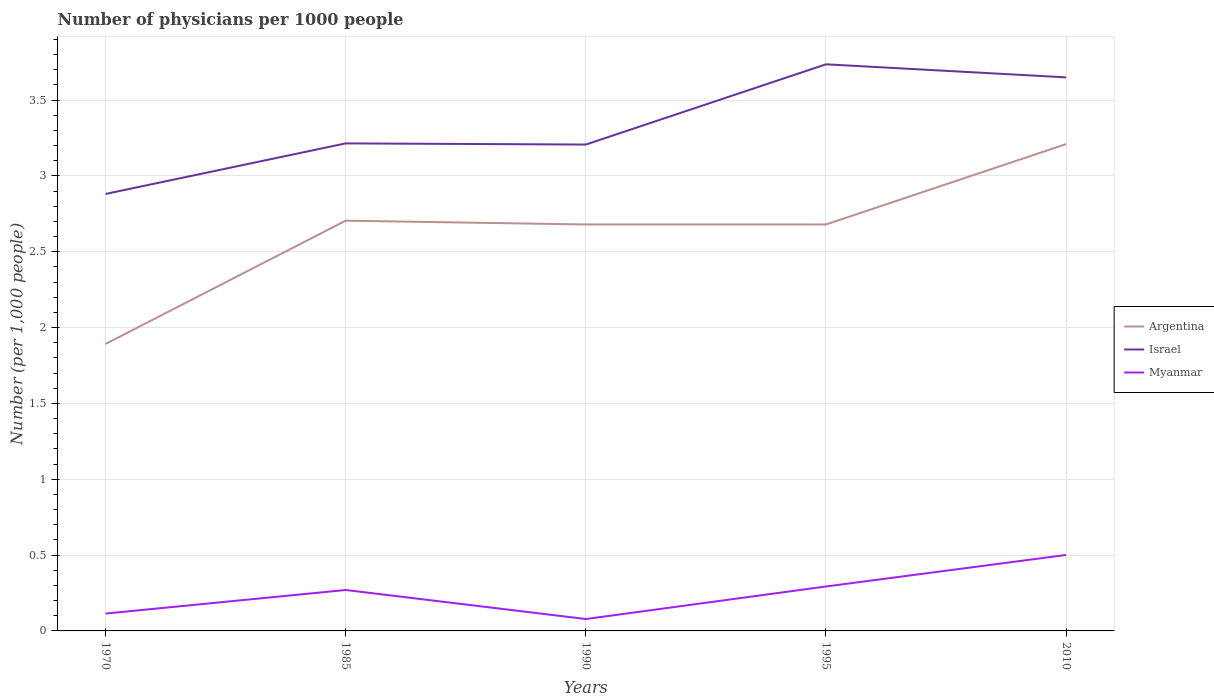Does the line corresponding to Israel intersect with the line corresponding to Argentina?
Your answer should be very brief. No. Across all years, what is the maximum number of physicians in Myanmar?
Make the answer very short. 0.08. What is the total number of physicians in Myanmar in the graph?
Your answer should be very brief. -0.21. What is the difference between the highest and the second highest number of physicians in Argentina?
Provide a short and direct response. 1.32. Is the number of physicians in Argentina strictly greater than the number of physicians in Israel over the years?
Your answer should be compact. Yes. How many lines are there?
Your answer should be compact. 3. Where does the legend appear in the graph?
Ensure brevity in your answer.  Center right. How are the legend labels stacked?
Your answer should be compact. Vertical. What is the title of the graph?
Make the answer very short. Number of physicians per 1000 people. Does "Hong Kong" appear as one of the legend labels in the graph?
Provide a short and direct response. No. What is the label or title of the X-axis?
Offer a terse response. Years. What is the label or title of the Y-axis?
Provide a succinct answer. Number (per 1,0 people). What is the Number (per 1,000 people) in Argentina in 1970?
Offer a very short reply. 1.89. What is the Number (per 1,000 people) in Israel in 1970?
Your answer should be compact. 2.88. What is the Number (per 1,000 people) in Myanmar in 1970?
Ensure brevity in your answer.  0.11. What is the Number (per 1,000 people) in Argentina in 1985?
Ensure brevity in your answer.  2.7. What is the Number (per 1,000 people) in Israel in 1985?
Keep it short and to the point. 3.21. What is the Number (per 1,000 people) in Myanmar in 1985?
Provide a succinct answer. 0.27. What is the Number (per 1,000 people) of Argentina in 1990?
Your answer should be compact. 2.68. What is the Number (per 1,000 people) in Israel in 1990?
Offer a very short reply. 3.21. What is the Number (per 1,000 people) in Myanmar in 1990?
Ensure brevity in your answer.  0.08. What is the Number (per 1,000 people) of Argentina in 1995?
Make the answer very short. 2.68. What is the Number (per 1,000 people) of Israel in 1995?
Make the answer very short. 3.74. What is the Number (per 1,000 people) in Myanmar in 1995?
Your answer should be very brief. 0.29. What is the Number (per 1,000 people) of Argentina in 2010?
Give a very brief answer. 3.21. What is the Number (per 1,000 people) in Israel in 2010?
Make the answer very short. 3.65. What is the Number (per 1,000 people) in Myanmar in 2010?
Keep it short and to the point. 0.5. Across all years, what is the maximum Number (per 1,000 people) in Argentina?
Provide a succinct answer. 3.21. Across all years, what is the maximum Number (per 1,000 people) in Israel?
Your answer should be very brief. 3.74. Across all years, what is the maximum Number (per 1,000 people) of Myanmar?
Provide a short and direct response. 0.5. Across all years, what is the minimum Number (per 1,000 people) in Argentina?
Make the answer very short. 1.89. Across all years, what is the minimum Number (per 1,000 people) of Israel?
Ensure brevity in your answer.  2.88. Across all years, what is the minimum Number (per 1,000 people) in Myanmar?
Make the answer very short. 0.08. What is the total Number (per 1,000 people) of Argentina in the graph?
Provide a succinct answer. 13.17. What is the total Number (per 1,000 people) of Israel in the graph?
Provide a succinct answer. 16.69. What is the total Number (per 1,000 people) of Myanmar in the graph?
Ensure brevity in your answer.  1.26. What is the difference between the Number (per 1,000 people) in Argentina in 1970 and that in 1985?
Give a very brief answer. -0.81. What is the difference between the Number (per 1,000 people) in Israel in 1970 and that in 1985?
Offer a very short reply. -0.33. What is the difference between the Number (per 1,000 people) in Myanmar in 1970 and that in 1985?
Your answer should be compact. -0.16. What is the difference between the Number (per 1,000 people) in Argentina in 1970 and that in 1990?
Make the answer very short. -0.79. What is the difference between the Number (per 1,000 people) of Israel in 1970 and that in 1990?
Make the answer very short. -0.33. What is the difference between the Number (per 1,000 people) in Myanmar in 1970 and that in 1990?
Provide a short and direct response. 0.04. What is the difference between the Number (per 1,000 people) in Argentina in 1970 and that in 1995?
Give a very brief answer. -0.79. What is the difference between the Number (per 1,000 people) of Israel in 1970 and that in 1995?
Provide a succinct answer. -0.85. What is the difference between the Number (per 1,000 people) of Myanmar in 1970 and that in 1995?
Keep it short and to the point. -0.18. What is the difference between the Number (per 1,000 people) in Argentina in 1970 and that in 2010?
Make the answer very short. -1.32. What is the difference between the Number (per 1,000 people) of Israel in 1970 and that in 2010?
Offer a very short reply. -0.77. What is the difference between the Number (per 1,000 people) of Myanmar in 1970 and that in 2010?
Your answer should be compact. -0.39. What is the difference between the Number (per 1,000 people) in Argentina in 1985 and that in 1990?
Keep it short and to the point. 0.03. What is the difference between the Number (per 1,000 people) in Israel in 1985 and that in 1990?
Your answer should be very brief. 0.01. What is the difference between the Number (per 1,000 people) of Myanmar in 1985 and that in 1990?
Offer a very short reply. 0.19. What is the difference between the Number (per 1,000 people) of Argentina in 1985 and that in 1995?
Offer a very short reply. 0.03. What is the difference between the Number (per 1,000 people) in Israel in 1985 and that in 1995?
Your answer should be very brief. -0.52. What is the difference between the Number (per 1,000 people) in Myanmar in 1985 and that in 1995?
Your response must be concise. -0.02. What is the difference between the Number (per 1,000 people) of Argentina in 1985 and that in 2010?
Offer a terse response. -0.51. What is the difference between the Number (per 1,000 people) of Israel in 1985 and that in 2010?
Your answer should be very brief. -0.44. What is the difference between the Number (per 1,000 people) of Myanmar in 1985 and that in 2010?
Offer a terse response. -0.23. What is the difference between the Number (per 1,000 people) of Israel in 1990 and that in 1995?
Ensure brevity in your answer.  -0.53. What is the difference between the Number (per 1,000 people) of Myanmar in 1990 and that in 1995?
Give a very brief answer. -0.21. What is the difference between the Number (per 1,000 people) in Argentina in 1990 and that in 2010?
Ensure brevity in your answer.  -0.53. What is the difference between the Number (per 1,000 people) of Israel in 1990 and that in 2010?
Provide a short and direct response. -0.44. What is the difference between the Number (per 1,000 people) of Myanmar in 1990 and that in 2010?
Ensure brevity in your answer.  -0.42. What is the difference between the Number (per 1,000 people) in Argentina in 1995 and that in 2010?
Provide a succinct answer. -0.53. What is the difference between the Number (per 1,000 people) of Israel in 1995 and that in 2010?
Provide a short and direct response. 0.09. What is the difference between the Number (per 1,000 people) in Myanmar in 1995 and that in 2010?
Provide a succinct answer. -0.21. What is the difference between the Number (per 1,000 people) in Argentina in 1970 and the Number (per 1,000 people) in Israel in 1985?
Keep it short and to the point. -1.32. What is the difference between the Number (per 1,000 people) of Argentina in 1970 and the Number (per 1,000 people) of Myanmar in 1985?
Provide a short and direct response. 1.62. What is the difference between the Number (per 1,000 people) in Israel in 1970 and the Number (per 1,000 people) in Myanmar in 1985?
Offer a very short reply. 2.61. What is the difference between the Number (per 1,000 people) of Argentina in 1970 and the Number (per 1,000 people) of Israel in 1990?
Give a very brief answer. -1.31. What is the difference between the Number (per 1,000 people) of Argentina in 1970 and the Number (per 1,000 people) of Myanmar in 1990?
Offer a terse response. 1.81. What is the difference between the Number (per 1,000 people) of Israel in 1970 and the Number (per 1,000 people) of Myanmar in 1990?
Provide a short and direct response. 2.8. What is the difference between the Number (per 1,000 people) of Argentina in 1970 and the Number (per 1,000 people) of Israel in 1995?
Offer a terse response. -1.84. What is the difference between the Number (per 1,000 people) in Argentina in 1970 and the Number (per 1,000 people) in Myanmar in 1995?
Ensure brevity in your answer.  1.6. What is the difference between the Number (per 1,000 people) in Israel in 1970 and the Number (per 1,000 people) in Myanmar in 1995?
Your answer should be very brief. 2.59. What is the difference between the Number (per 1,000 people) of Argentina in 1970 and the Number (per 1,000 people) of Israel in 2010?
Offer a terse response. -1.76. What is the difference between the Number (per 1,000 people) of Argentina in 1970 and the Number (per 1,000 people) of Myanmar in 2010?
Provide a short and direct response. 1.39. What is the difference between the Number (per 1,000 people) in Israel in 1970 and the Number (per 1,000 people) in Myanmar in 2010?
Provide a short and direct response. 2.38. What is the difference between the Number (per 1,000 people) in Argentina in 1985 and the Number (per 1,000 people) in Israel in 1990?
Your answer should be very brief. -0.5. What is the difference between the Number (per 1,000 people) of Argentina in 1985 and the Number (per 1,000 people) of Myanmar in 1990?
Give a very brief answer. 2.63. What is the difference between the Number (per 1,000 people) of Israel in 1985 and the Number (per 1,000 people) of Myanmar in 1990?
Make the answer very short. 3.14. What is the difference between the Number (per 1,000 people) of Argentina in 1985 and the Number (per 1,000 people) of Israel in 1995?
Give a very brief answer. -1.03. What is the difference between the Number (per 1,000 people) in Argentina in 1985 and the Number (per 1,000 people) in Myanmar in 1995?
Your answer should be compact. 2.41. What is the difference between the Number (per 1,000 people) in Israel in 1985 and the Number (per 1,000 people) in Myanmar in 1995?
Offer a very short reply. 2.92. What is the difference between the Number (per 1,000 people) in Argentina in 1985 and the Number (per 1,000 people) in Israel in 2010?
Provide a succinct answer. -0.94. What is the difference between the Number (per 1,000 people) of Argentina in 1985 and the Number (per 1,000 people) of Myanmar in 2010?
Ensure brevity in your answer.  2.2. What is the difference between the Number (per 1,000 people) of Israel in 1985 and the Number (per 1,000 people) of Myanmar in 2010?
Make the answer very short. 2.71. What is the difference between the Number (per 1,000 people) of Argentina in 1990 and the Number (per 1,000 people) of Israel in 1995?
Provide a succinct answer. -1.06. What is the difference between the Number (per 1,000 people) of Argentina in 1990 and the Number (per 1,000 people) of Myanmar in 1995?
Offer a terse response. 2.39. What is the difference between the Number (per 1,000 people) of Israel in 1990 and the Number (per 1,000 people) of Myanmar in 1995?
Your response must be concise. 2.91. What is the difference between the Number (per 1,000 people) in Argentina in 1990 and the Number (per 1,000 people) in Israel in 2010?
Offer a terse response. -0.97. What is the difference between the Number (per 1,000 people) in Argentina in 1990 and the Number (per 1,000 people) in Myanmar in 2010?
Your response must be concise. 2.18. What is the difference between the Number (per 1,000 people) in Israel in 1990 and the Number (per 1,000 people) in Myanmar in 2010?
Make the answer very short. 2.71. What is the difference between the Number (per 1,000 people) of Argentina in 1995 and the Number (per 1,000 people) of Israel in 2010?
Ensure brevity in your answer.  -0.97. What is the difference between the Number (per 1,000 people) of Argentina in 1995 and the Number (per 1,000 people) of Myanmar in 2010?
Provide a succinct answer. 2.18. What is the difference between the Number (per 1,000 people) in Israel in 1995 and the Number (per 1,000 people) in Myanmar in 2010?
Make the answer very short. 3.23. What is the average Number (per 1,000 people) of Argentina per year?
Provide a succinct answer. 2.63. What is the average Number (per 1,000 people) in Israel per year?
Provide a short and direct response. 3.34. What is the average Number (per 1,000 people) in Myanmar per year?
Keep it short and to the point. 0.25. In the year 1970, what is the difference between the Number (per 1,000 people) in Argentina and Number (per 1,000 people) in Israel?
Offer a very short reply. -0.99. In the year 1970, what is the difference between the Number (per 1,000 people) of Argentina and Number (per 1,000 people) of Myanmar?
Offer a terse response. 1.78. In the year 1970, what is the difference between the Number (per 1,000 people) in Israel and Number (per 1,000 people) in Myanmar?
Keep it short and to the point. 2.77. In the year 1985, what is the difference between the Number (per 1,000 people) in Argentina and Number (per 1,000 people) in Israel?
Offer a terse response. -0.51. In the year 1985, what is the difference between the Number (per 1,000 people) of Argentina and Number (per 1,000 people) of Myanmar?
Keep it short and to the point. 2.44. In the year 1985, what is the difference between the Number (per 1,000 people) of Israel and Number (per 1,000 people) of Myanmar?
Your response must be concise. 2.94. In the year 1990, what is the difference between the Number (per 1,000 people) in Argentina and Number (per 1,000 people) in Israel?
Offer a very short reply. -0.53. In the year 1990, what is the difference between the Number (per 1,000 people) of Argentina and Number (per 1,000 people) of Myanmar?
Ensure brevity in your answer.  2.6. In the year 1990, what is the difference between the Number (per 1,000 people) in Israel and Number (per 1,000 people) in Myanmar?
Your response must be concise. 3.13. In the year 1995, what is the difference between the Number (per 1,000 people) in Argentina and Number (per 1,000 people) in Israel?
Your response must be concise. -1.06. In the year 1995, what is the difference between the Number (per 1,000 people) in Argentina and Number (per 1,000 people) in Myanmar?
Provide a succinct answer. 2.39. In the year 1995, what is the difference between the Number (per 1,000 people) of Israel and Number (per 1,000 people) of Myanmar?
Your answer should be compact. 3.44. In the year 2010, what is the difference between the Number (per 1,000 people) in Argentina and Number (per 1,000 people) in Israel?
Give a very brief answer. -0.44. In the year 2010, what is the difference between the Number (per 1,000 people) in Argentina and Number (per 1,000 people) in Myanmar?
Your answer should be very brief. 2.71. In the year 2010, what is the difference between the Number (per 1,000 people) of Israel and Number (per 1,000 people) of Myanmar?
Give a very brief answer. 3.15. What is the ratio of the Number (per 1,000 people) of Argentina in 1970 to that in 1985?
Offer a terse response. 0.7. What is the ratio of the Number (per 1,000 people) in Israel in 1970 to that in 1985?
Give a very brief answer. 0.9. What is the ratio of the Number (per 1,000 people) of Myanmar in 1970 to that in 1985?
Offer a very short reply. 0.42. What is the ratio of the Number (per 1,000 people) of Argentina in 1970 to that in 1990?
Your answer should be compact. 0.71. What is the ratio of the Number (per 1,000 people) in Israel in 1970 to that in 1990?
Your answer should be compact. 0.9. What is the ratio of the Number (per 1,000 people) of Myanmar in 1970 to that in 1990?
Your answer should be compact. 1.46. What is the ratio of the Number (per 1,000 people) in Argentina in 1970 to that in 1995?
Give a very brief answer. 0.71. What is the ratio of the Number (per 1,000 people) of Israel in 1970 to that in 1995?
Make the answer very short. 0.77. What is the ratio of the Number (per 1,000 people) in Myanmar in 1970 to that in 1995?
Keep it short and to the point. 0.39. What is the ratio of the Number (per 1,000 people) of Argentina in 1970 to that in 2010?
Offer a very short reply. 0.59. What is the ratio of the Number (per 1,000 people) of Israel in 1970 to that in 2010?
Your answer should be very brief. 0.79. What is the ratio of the Number (per 1,000 people) in Myanmar in 1970 to that in 2010?
Offer a terse response. 0.23. What is the ratio of the Number (per 1,000 people) in Argentina in 1985 to that in 1990?
Ensure brevity in your answer.  1.01. What is the ratio of the Number (per 1,000 people) in Myanmar in 1985 to that in 1990?
Make the answer very short. 3.44. What is the ratio of the Number (per 1,000 people) in Argentina in 1985 to that in 1995?
Provide a succinct answer. 1.01. What is the ratio of the Number (per 1,000 people) of Israel in 1985 to that in 1995?
Your answer should be very brief. 0.86. What is the ratio of the Number (per 1,000 people) of Myanmar in 1985 to that in 1995?
Provide a succinct answer. 0.92. What is the ratio of the Number (per 1,000 people) of Argentina in 1985 to that in 2010?
Your answer should be very brief. 0.84. What is the ratio of the Number (per 1,000 people) of Israel in 1985 to that in 2010?
Provide a short and direct response. 0.88. What is the ratio of the Number (per 1,000 people) of Myanmar in 1985 to that in 2010?
Your response must be concise. 0.54. What is the ratio of the Number (per 1,000 people) in Israel in 1990 to that in 1995?
Offer a very short reply. 0.86. What is the ratio of the Number (per 1,000 people) in Myanmar in 1990 to that in 1995?
Provide a succinct answer. 0.27. What is the ratio of the Number (per 1,000 people) in Argentina in 1990 to that in 2010?
Give a very brief answer. 0.83. What is the ratio of the Number (per 1,000 people) of Israel in 1990 to that in 2010?
Offer a very short reply. 0.88. What is the ratio of the Number (per 1,000 people) of Myanmar in 1990 to that in 2010?
Your answer should be very brief. 0.16. What is the ratio of the Number (per 1,000 people) in Argentina in 1995 to that in 2010?
Ensure brevity in your answer.  0.83. What is the ratio of the Number (per 1,000 people) in Israel in 1995 to that in 2010?
Give a very brief answer. 1.02. What is the ratio of the Number (per 1,000 people) of Myanmar in 1995 to that in 2010?
Ensure brevity in your answer.  0.58. What is the difference between the highest and the second highest Number (per 1,000 people) in Argentina?
Ensure brevity in your answer.  0.51. What is the difference between the highest and the second highest Number (per 1,000 people) of Israel?
Keep it short and to the point. 0.09. What is the difference between the highest and the second highest Number (per 1,000 people) in Myanmar?
Offer a very short reply. 0.21. What is the difference between the highest and the lowest Number (per 1,000 people) in Argentina?
Your answer should be compact. 1.32. What is the difference between the highest and the lowest Number (per 1,000 people) in Israel?
Keep it short and to the point. 0.85. What is the difference between the highest and the lowest Number (per 1,000 people) of Myanmar?
Keep it short and to the point. 0.42. 